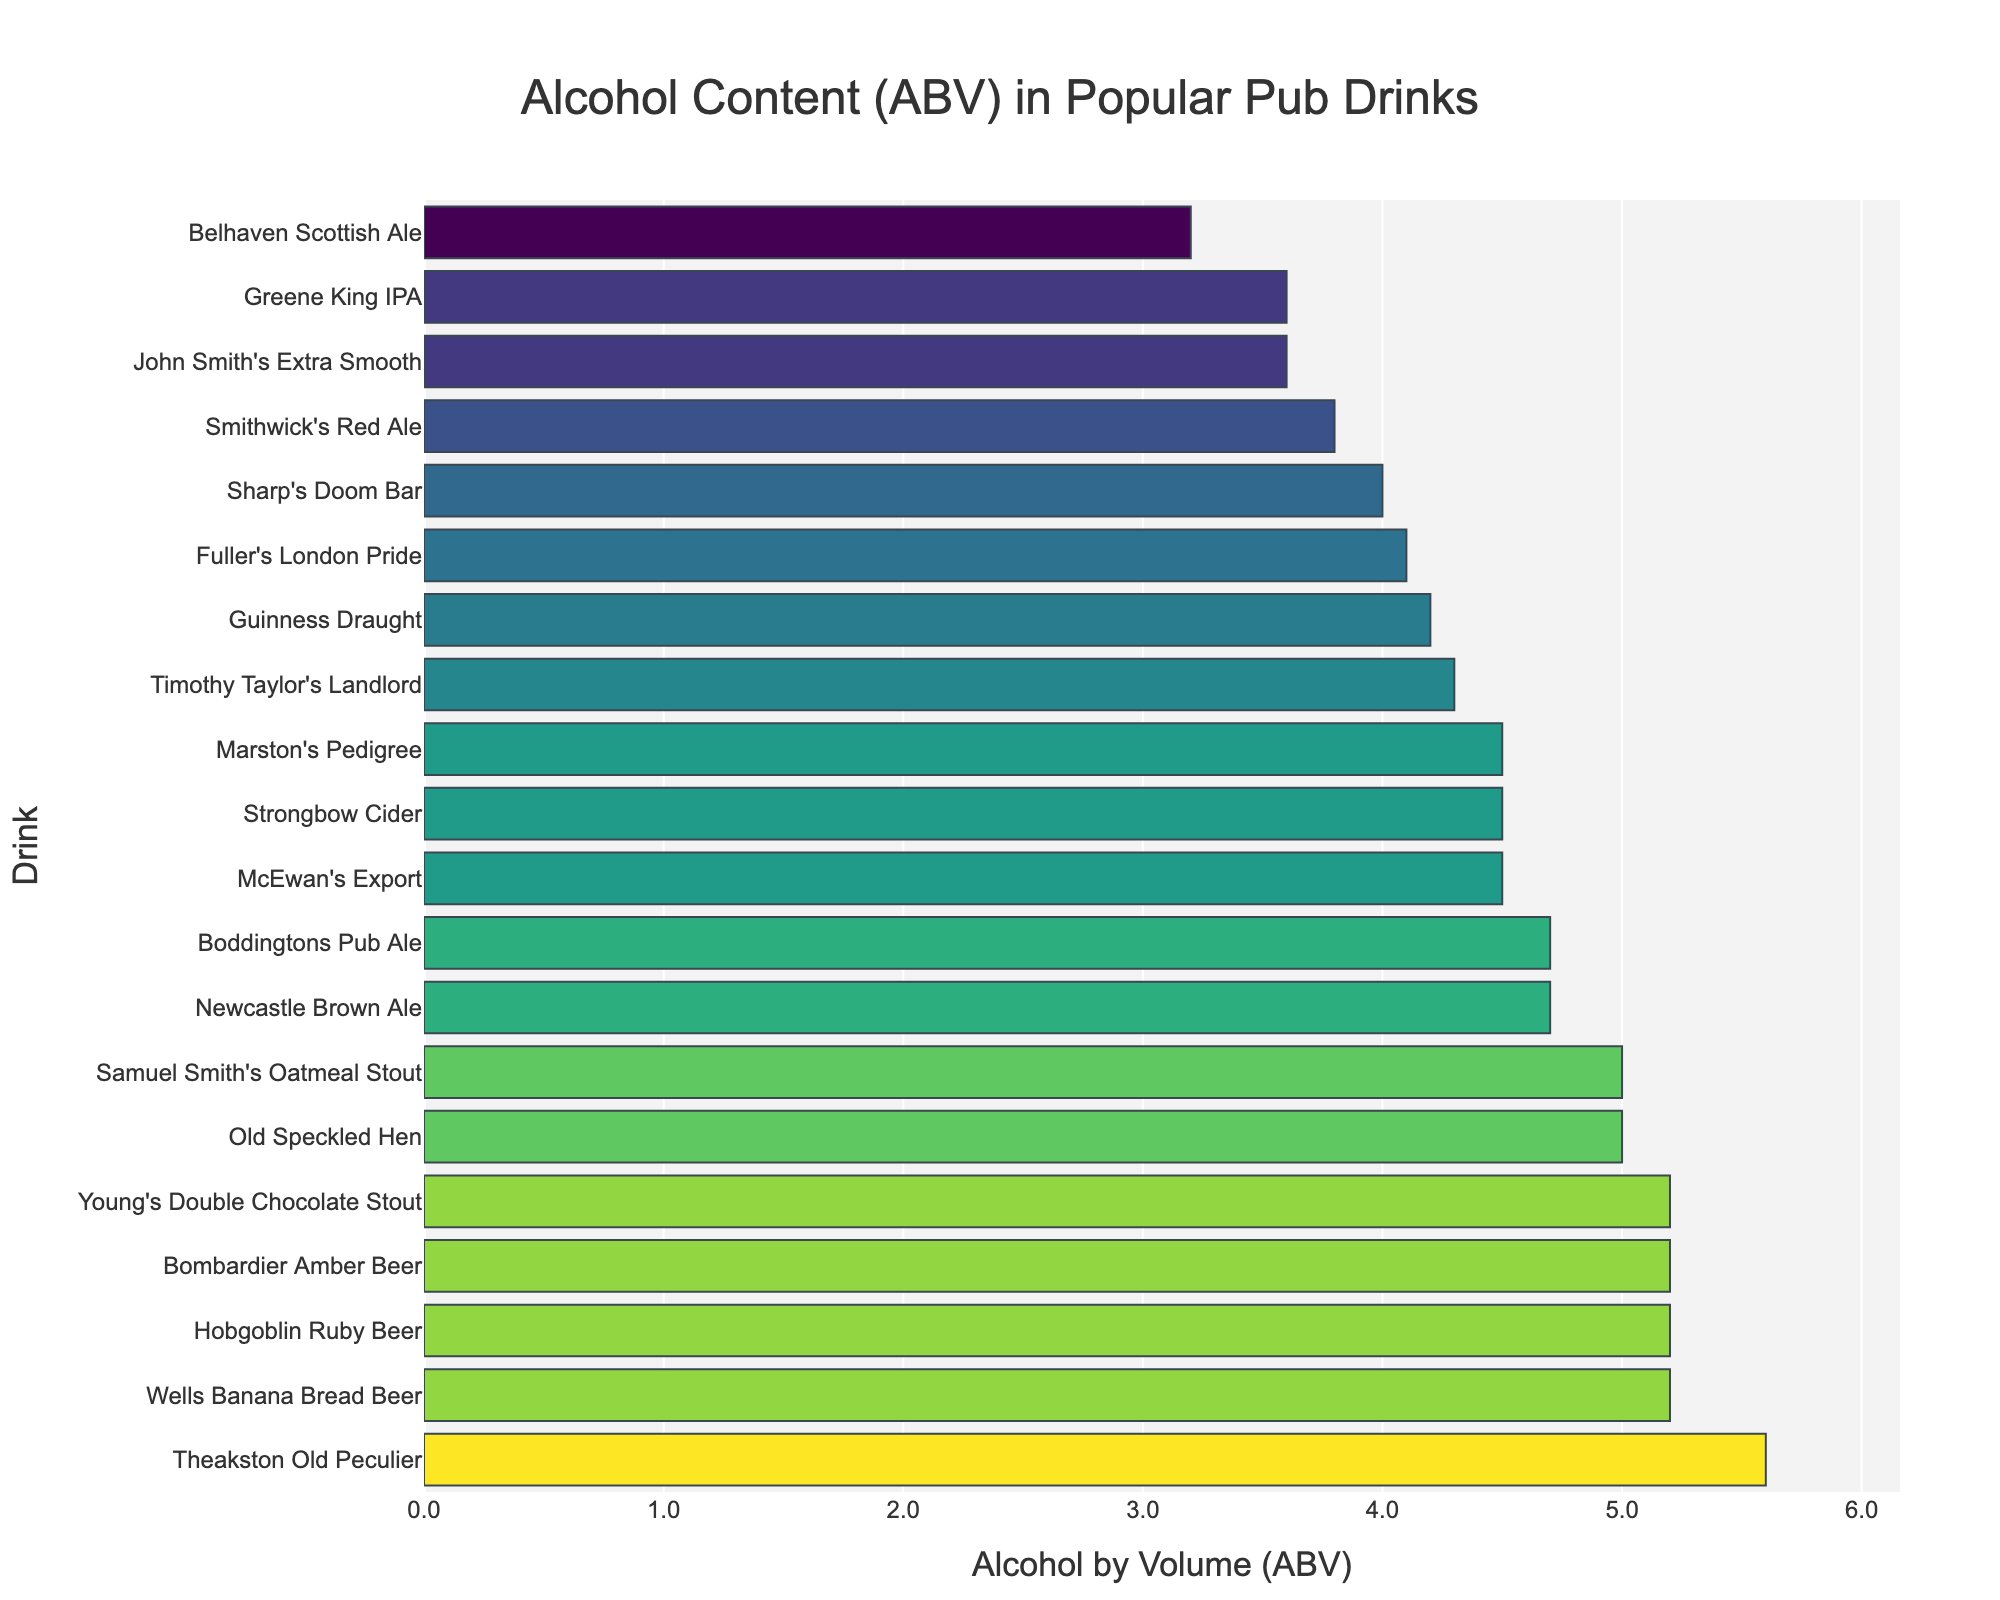Which drink has the highest ABV? The drink with the highest ABV is shown at the top of the bar plot because the plot is sorted in descending order of ABV. The topmost drink is "Theakston Old Peculier" with an ABV of 5.6.
Answer: Theakston Old Peculier How many drinks have an ABV greater than 5.0%? To find the number of drinks with an ABV greater than 5.0%, count the bars where the x-axis value exceeds 5.0. There are six drinks: Old Speckled Hen, Bombardier Amber Beer, Young's Double Chocolate Stout, Wells Banana Bread Beer, Hobgoblin Ruby Beer, and Theakston Old Peculier.
Answer: Six What is the average ABV of all the drinks? Sum the ABV values of all drinks and divide by the total number of drinks. The ABV values sum to 82.3 across 20 drinks. Therefore, the average ABV is 82.3 / 20 = 4.115.
Answer: 4.12 Which drink has the lowest ABV? The drink with the lowest ABV is shown at the bottom of the bar plot, as the plot is sorted in descending order of ABV. The bottommost drink is "Belhaven Scottish Ale" with an ABV of 3.2.
Answer: Belhaven Scottish Ale What is the range of ABV across the drinks? To find the range, subtract the lowest ABV value from the highest ABV value. The highest ABV is 5.6 (Theakston Old Peculier) and the lowest is 3.2 (Belhaven Scottish Ale). Thus, the range is 5.6 - 3.2.
Answer: 2.4 Is there a drink with exactly 4.5% ABV? Look for a bar on the plot corresponding to an ABV value of 4.5%. There are three drinks with an ABV of 4.5%: Strongbow Cider, Marston's Pedigree, and McEwan's Export.
Answer: Yes. Three drinks How many drinks have an ABV below 4.0%? Count the bars where the x-axis value is below 4.0% ABV. There are three such drinks: Smithwick's Red Ale (3.8%), Greene King IPA (3.6%), and John Smith's Extra Smooth (3.6%).
Answer: Three Which drink has the closest ABV to 5.0%? Find the drink whose ABV is closest to 5.0%. By comparing values, Samuel Smith's Oatmeal Stout and Old Speckled Hen both have an ABV equal to 5.0%.
Answer: Samuel Smith's Oatmeal Stout and Old Speckled Hen What is the median ABV of the drinks? To find the median, sort all ABV values in ascending order and locate the middle value. There are 20 drinks, so the median will be the average of the 10th and 11th values. Ordered ABVs: [3.2, 3.6, 3.6, 3.8, 4.0, 4.1, 4.2, 4.3, 4.5, 4.5, 4.5, 4.7, 4.7, 5.0, 5.0, 5.2, 5.2, 5.2, 5.2, 5.6]. The median is (4.5+4.5)/2.
Answer: 4.5 What percentage of the drinks have an ABV between 4.0% and 5.0%? Count the number of drinks with an ABV between 4.0% and 5.0% and divide by the total number of drinks, then multiply by 100 to get the percentage. There are 11 such drinks out of 20. Percentage = (11/20) * 100.
Answer: 55% 